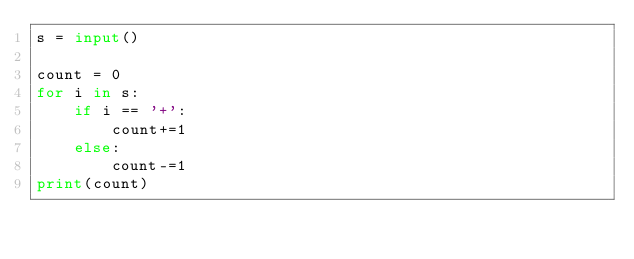<code> <loc_0><loc_0><loc_500><loc_500><_Python_>s = input()

count = 0
for i in s:
    if i == '+':
        count+=1
    else:
        count-=1
print(count)
 </code> 